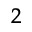Convert formula to latex. <formula><loc_0><loc_0><loc_500><loc_500>^ { 2 }</formula> 